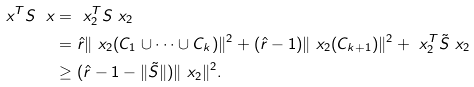<formula> <loc_0><loc_0><loc_500><loc_500>\ x ^ { T } S \ x & = \ x _ { 2 } ^ { T } S \ x _ { 2 } \\ & = \hat { r } \| \ x _ { 2 } ( C _ { 1 } \cup \dots \cup C _ { k } ) \| ^ { 2 } + ( \hat { r } - 1 ) \| \ x _ { 2 } ( C _ { k + 1 } ) \| ^ { 2 } + \ x _ { 2 } ^ { T } \tilde { S } \ x _ { 2 } \\ & \geq ( \hat { r } - 1 - \| \tilde { S } \| ) \| \ x _ { 2 } \| ^ { 2 } .</formula> 